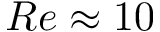Convert formula to latex. <formula><loc_0><loc_0><loc_500><loc_500>R e \approx 1 0</formula> 